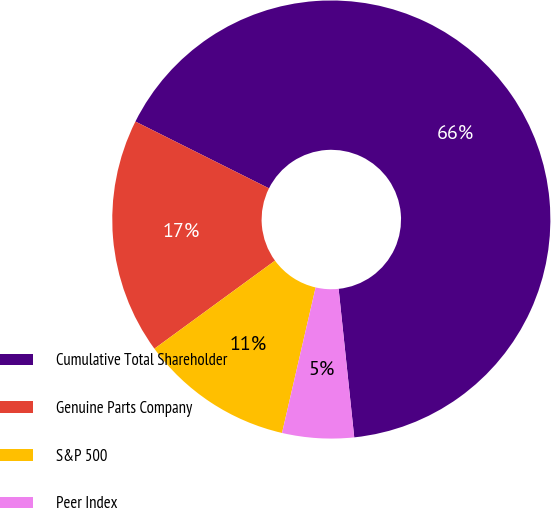Convert chart. <chart><loc_0><loc_0><loc_500><loc_500><pie_chart><fcel>Cumulative Total Shareholder<fcel>Genuine Parts Company<fcel>S&P 500<fcel>Peer Index<nl><fcel>65.95%<fcel>17.42%<fcel>11.35%<fcel>5.28%<nl></chart> 